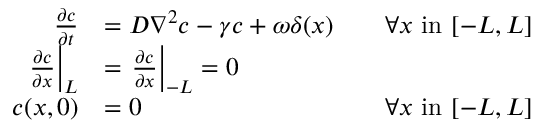Convert formula to latex. <formula><loc_0><loc_0><loc_500><loc_500>\begin{array} { r l r } { \frac { \partial c } { \partial t } } & { = D \nabla ^ { 2 } c - \gamma c + \omega \delta ( x ) } & { \quad \forall x i n [ - L , L ] } \\ { \frac { \partial c } { \partial x } \right | _ { L } } & { = \frac { \partial c } { \partial x } \right | _ { - L } = 0 } \\ { c ( x , 0 ) } & { = 0 } & { \forall x i n [ - L , L ] } \end{array}</formula> 